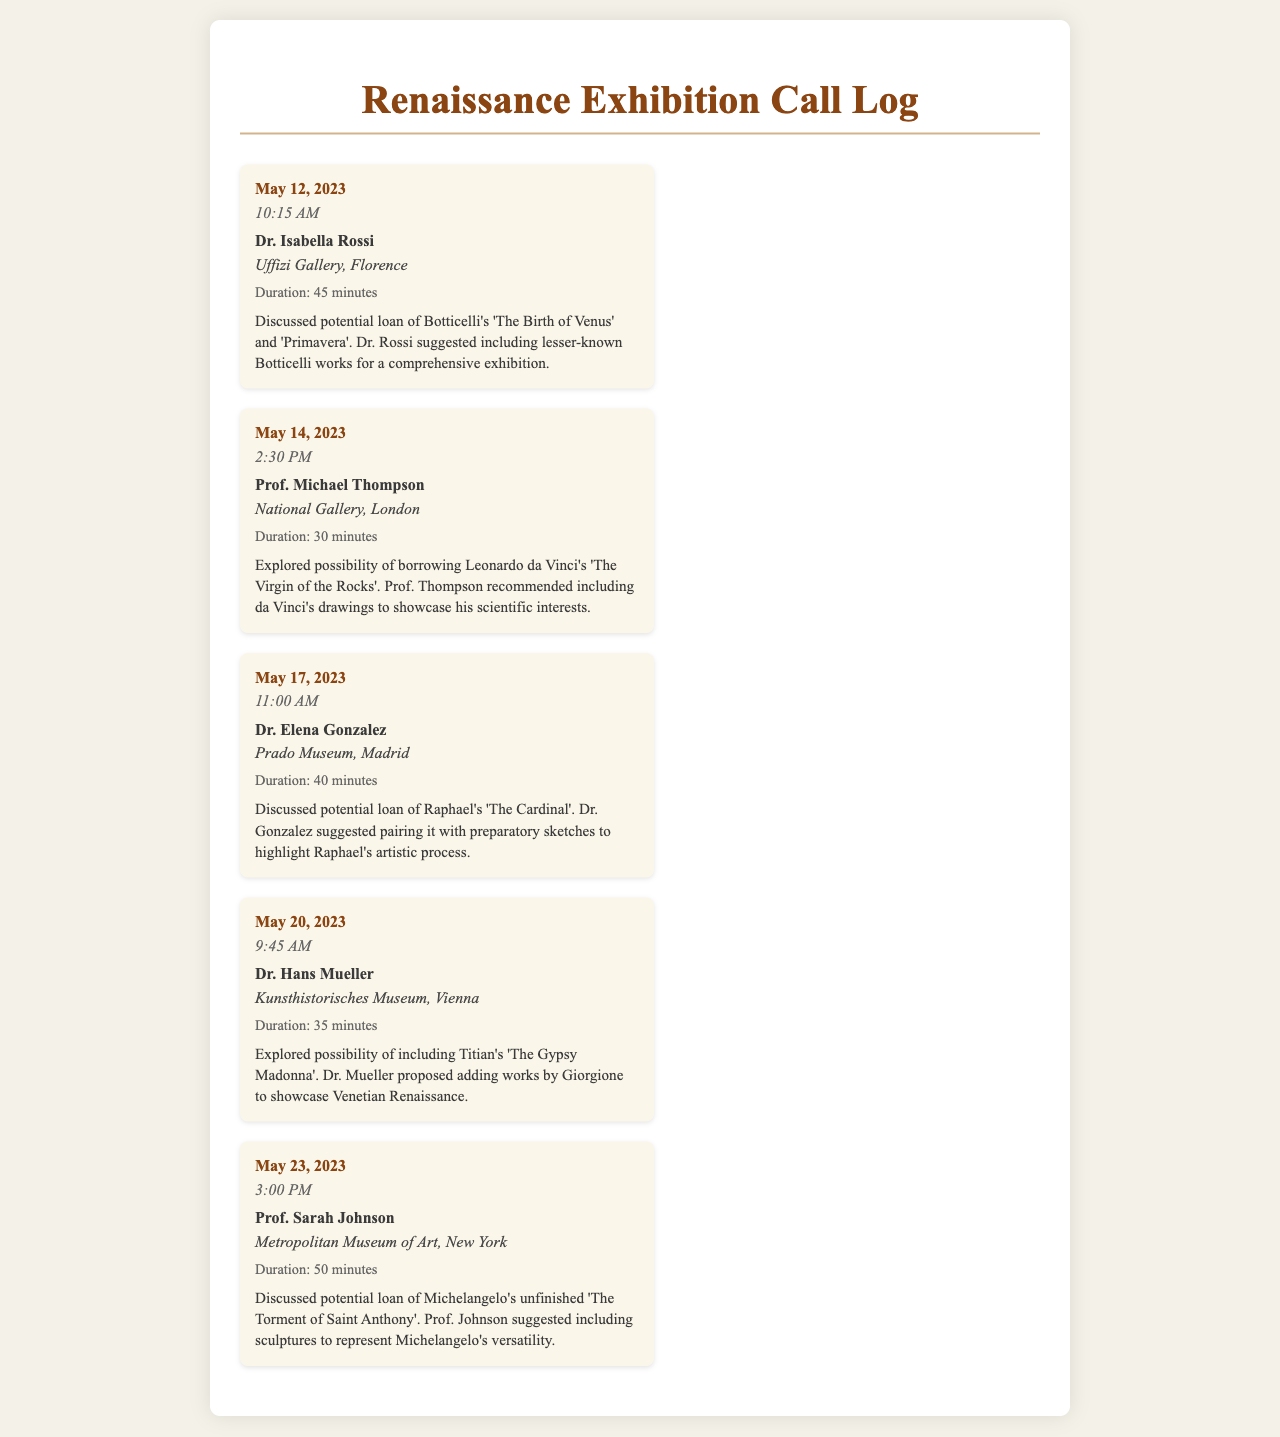What was discussed with Dr. Isabella Rossi? The summary mentions the potential loan of Botticelli's 'The Birth of Venus' and 'Primavera', and including lesser-known Botticelli works.
Answer: Botticelli's 'The Birth of Venus' and 'Primavera' Which artwork did Prof. Michael Thompson consider borrowing? The call summary states that they explored the possibility of borrowing Leonardo da Vinci's 'The Virgin of the Rocks'.
Answer: 'The Virgin of the Rocks' How long was the call with Dr. Elena Gonzalez? The duration of the call with Dr. Gonzalez is noted as 40 minutes.
Answer: 40 minutes What suggestion did Dr. Hans Mueller make regarding the exhibition? Dr. Mueller proposed adding works by Giorgione to showcase the Venetian Renaissance.
Answer: Adding works by Giorgione On what date was the last call made in the log? The last entry in the call log is dated May 23, 2023.
Answer: May 23, 2023 Who is associated with 'The Torment of Saint Anthony'? The call summary attributes the unfinished work to Michelangelo.
Answer: Michelangelo What is the duration of the call with Prof. Sarah Johnson? The duration for the call with Prof. Johnson is given as 50 minutes.
Answer: 50 minutes What type of works did Dr. Gonzalez suggest pairing with Raphael's 'The Cardinal'? Dr. Gonzalez suggested pairing it with preparatory sketches.
Answer: Preparatory sketches 